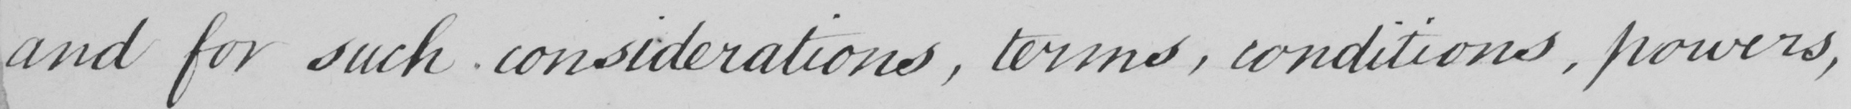Can you read and transcribe this handwriting? and for such considerations, terms, conditions, powers, 